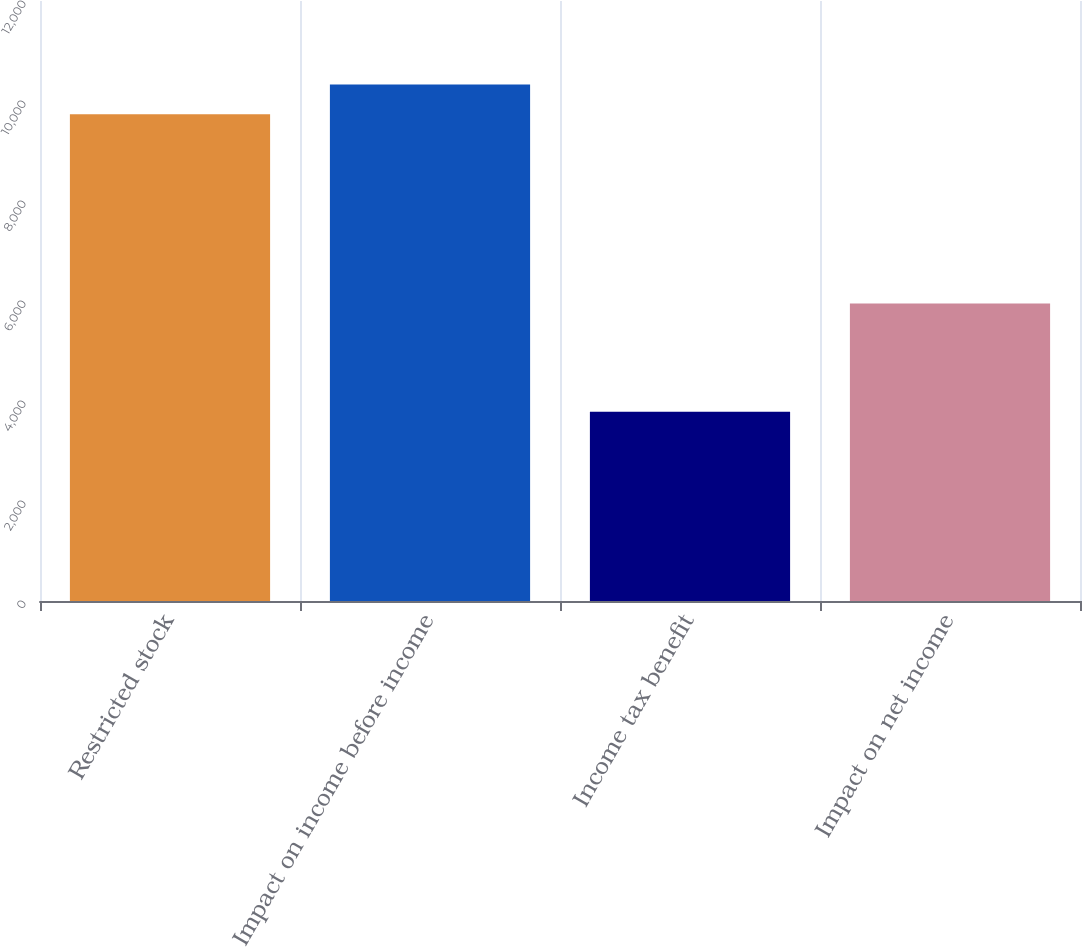<chart> <loc_0><loc_0><loc_500><loc_500><bar_chart><fcel>Restricted stock<fcel>Impact on income before income<fcel>Income tax benefit<fcel>Impact on net income<nl><fcel>9736<fcel>10331.2<fcel>3784<fcel>5952<nl></chart> 